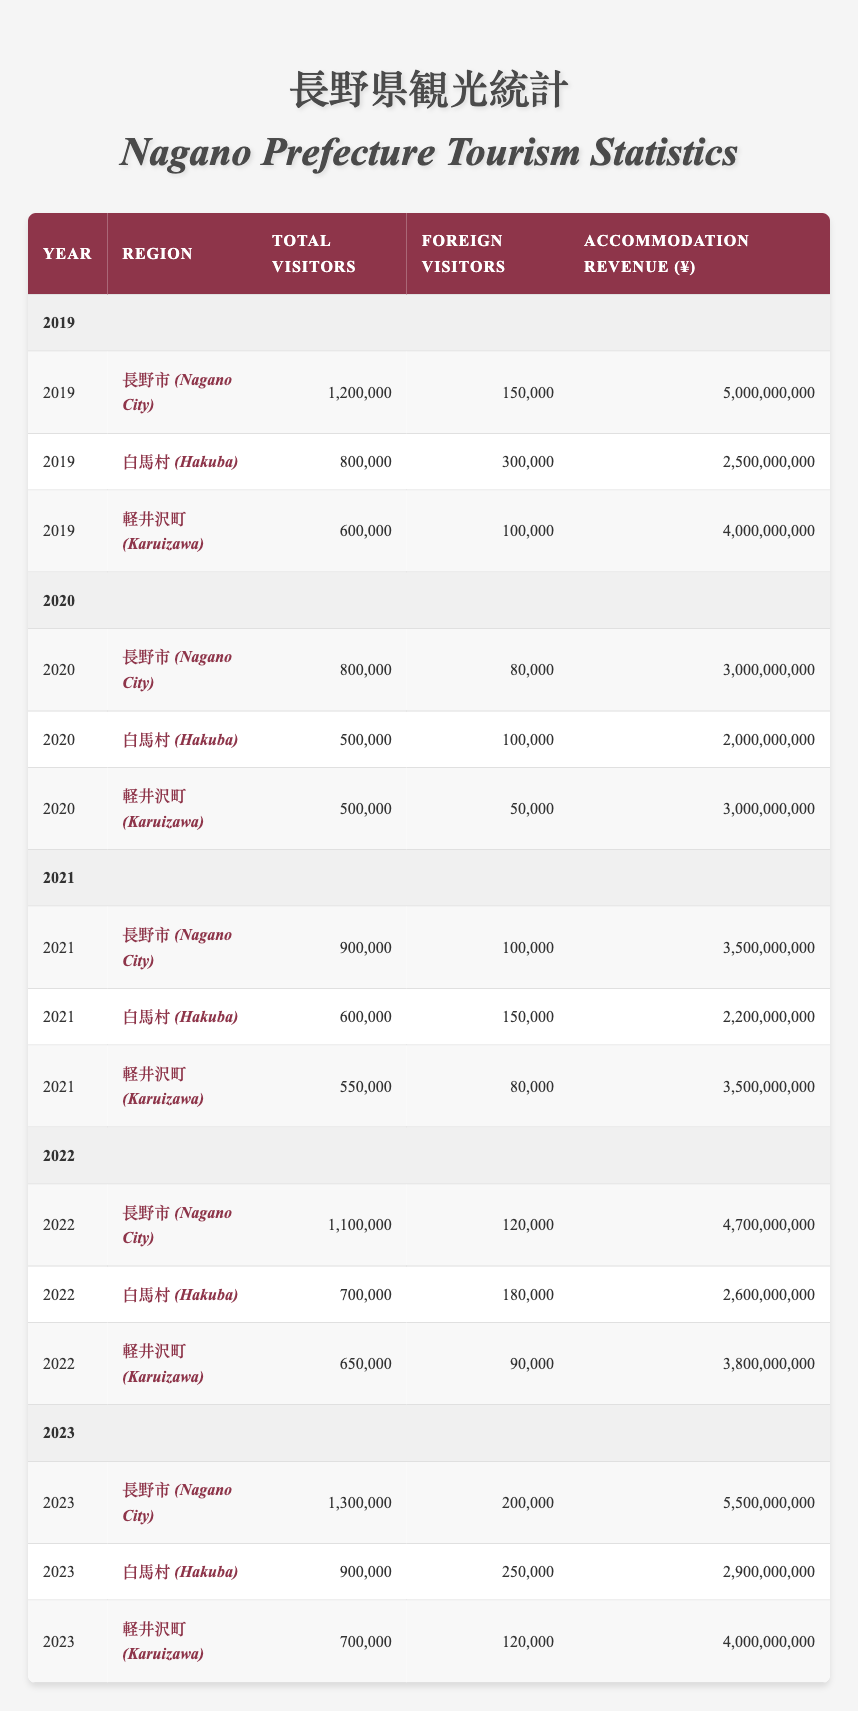What was the total accommodation revenue for Nagano City in 2022? According to the table, the accommodation revenue for Nagano City in 2022 is listed as ¥4,700,000,000.
Answer: ¥4,700,000,000 How many foreign visitors did Hakuba receive in 2021? The table shows that Hakuba had 150,000 foreign visitors in 2021.
Answer: 150,000 What was the increase in total visitors to Karuizawa from 2021 to 2022? In 2021, Karuizawa had 550,000 visitors, and in 2022 it had 650,000 visitors. The difference is 650,000 - 550,000 = 100,000.
Answer: 100,000 Which year had the highest total visitors in Nagano City? The highest total visitors in Nagano City were in 2023, with 1,300,000 visitors.
Answer: 2023 What was the total number of foreign visitors across all regions in 2019? Summing foreign visitors in 2019 gives 150,000 (Nagano City) + 300,000 (Hakuba) + 100,000 (Karuizawa) = 550,000 foreign visitors.
Answer: 550,000 Did the total number of visitors in Hakuba increase from 2020 to 2023? In 2020, Hakuba had 500,000 visitors, and in 2023 it had 900,000 visitors, which is an increase.
Answer: Yes What is the average accommodation revenue for Karuizawa from 2019 to 2023? The revenues from 2019 to 2023 are ¥4,000,000,000, ¥3,000,000,000, ¥3,500,000,000, ¥3,800,000,000, and ¥4,000,000,000. The sum is ¥18,300,000,000, and the average is ¥18,300,000,000 / 5 = ¥3,660,000,000.
Answer: ¥3,660,000,000 What year had the lowest accommodation revenue for Nagano City? The lowest accommodation revenue for Nagano City was in 2020, totaling ¥3,000,000,000.
Answer: 2020 Was the total number of visitors to Karuizawa greater than that in Hakuba in 2022? In 2022, Karuizawa had 650,000 visitors while Hakuba had 700,000 visitors, meaning Karuizawa had fewer visitors than Hakuba.
Answer: No Which region had the highest number of foreign visitors in 2023? In 2023, Hakuba had the highest number of foreign visitors with 250,000.
Answer: Hakuba 